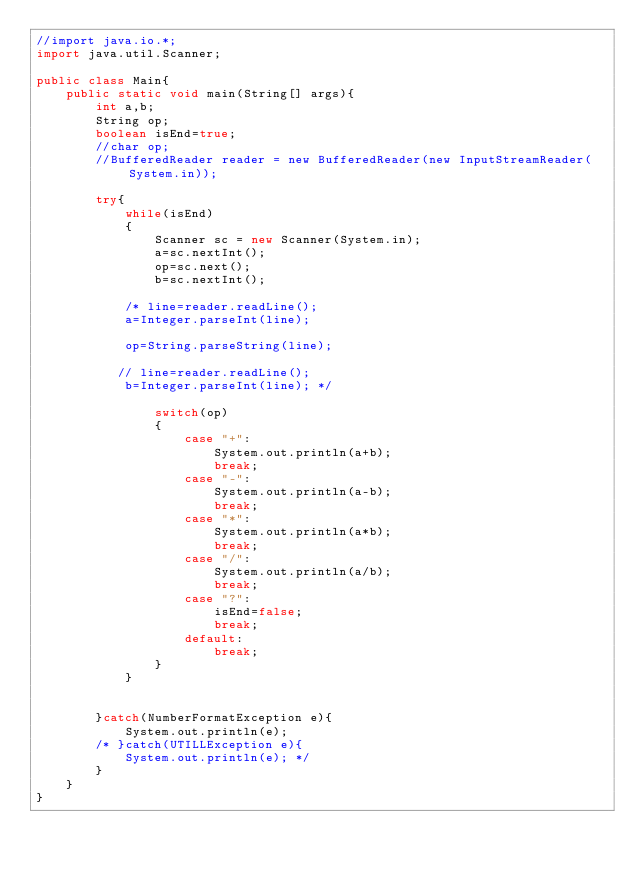<code> <loc_0><loc_0><loc_500><loc_500><_Java_>//import java.io.*;
import java.util.Scanner;

public class Main{
    public static void main(String[] args){
        int a,b;
        String op;
        boolean isEnd=true;
        //char op;
        //BufferedReader reader = new BufferedReader(new InputStreamReader(System.in));

        try{
            while(isEnd)
            {
                Scanner sc = new Scanner(System.in);
                a=sc.nextInt();
                op=sc.next();
                b=sc.nextInt();

            /* line=reader.readLine();
            a=Integer.parseInt(line);

            op=String.parseString(line);

           // line=reader.readLine();
            b=Integer.parseInt(line); */

                switch(op)
                {
                    case "+":
                        System.out.println(a+b);
                        break;
                    case "-":
                        System.out.println(a-b);
                        break;
                    case "*":
                        System.out.println(a*b);
                        break;
                    case "/":
                        System.out.println(a/b);
                        break;
                    case "?":
                        isEnd=false;
                        break;
                    default:
                        break;
                }
            }
            

        }catch(NumberFormatException e){
            System.out.println(e);
        /* }catch(UTILLException e){
            System.out.println(e); */
        }
    }
}
</code> 